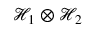Convert formula to latex. <formula><loc_0><loc_0><loc_500><loc_500>\mathcal { H } _ { 1 } \otimes \mathcal { H } _ { 2 }</formula> 